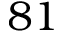Convert formula to latex. <formula><loc_0><loc_0><loc_500><loc_500>8 1</formula> 